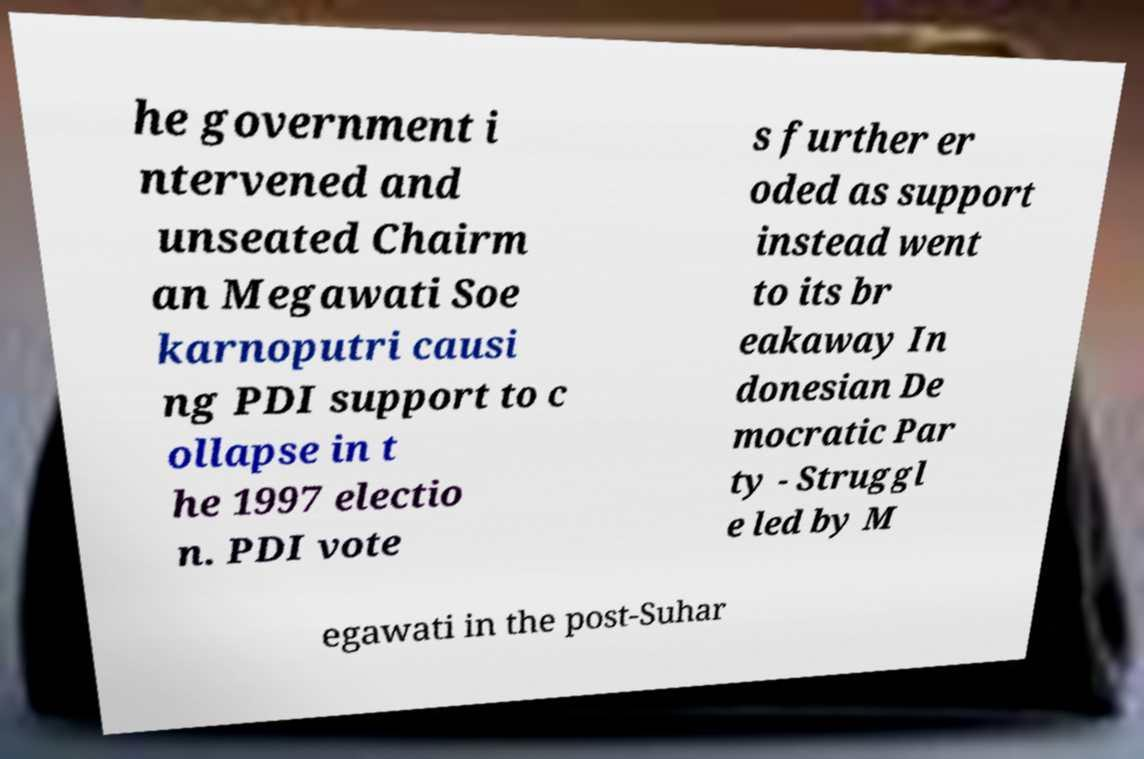What messages or text are displayed in this image? I need them in a readable, typed format. he government i ntervened and unseated Chairm an Megawati Soe karnoputri causi ng PDI support to c ollapse in t he 1997 electio n. PDI vote s further er oded as support instead went to its br eakaway In donesian De mocratic Par ty - Struggl e led by M egawati in the post-Suhar 